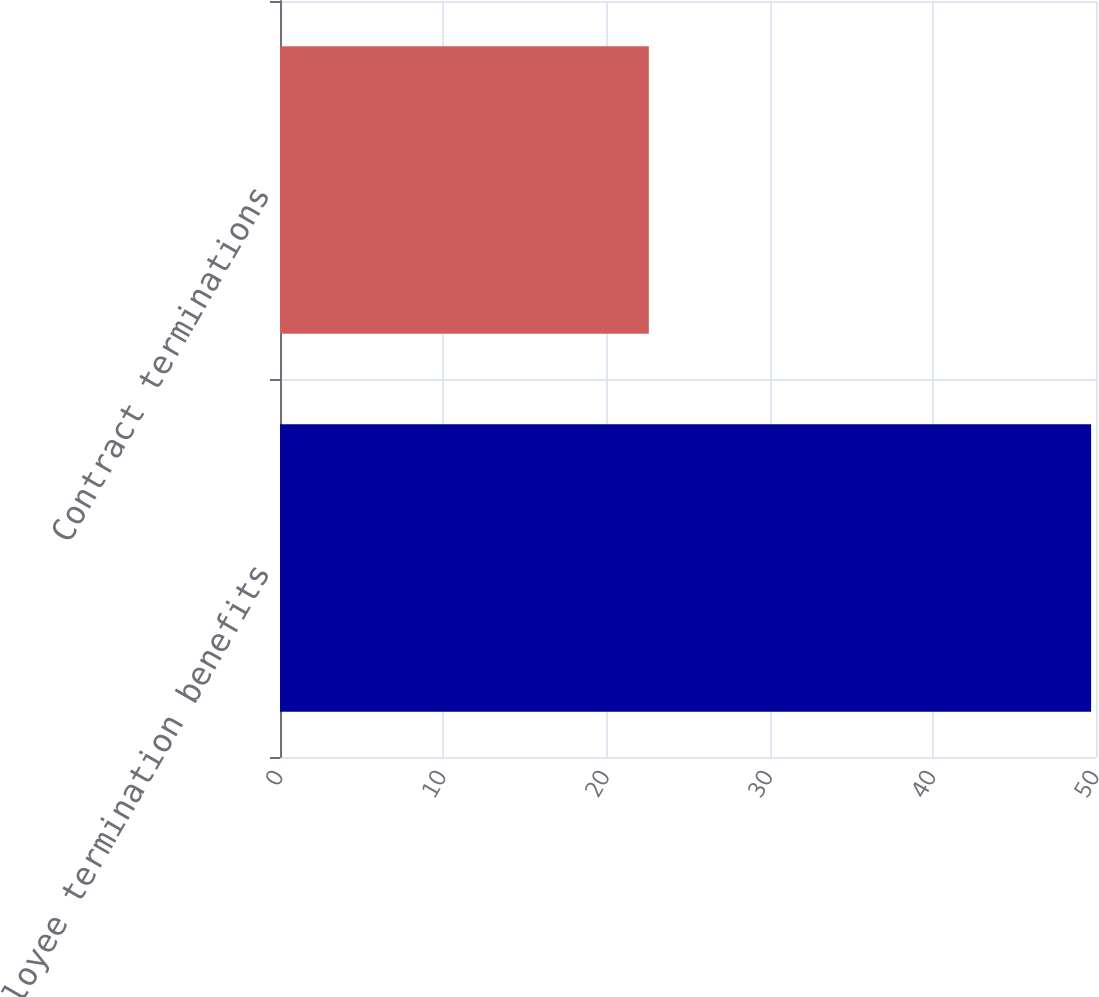<chart> <loc_0><loc_0><loc_500><loc_500><bar_chart><fcel>Employee termination benefits<fcel>Contract terminations<nl><fcel>49.7<fcel>22.6<nl></chart> 